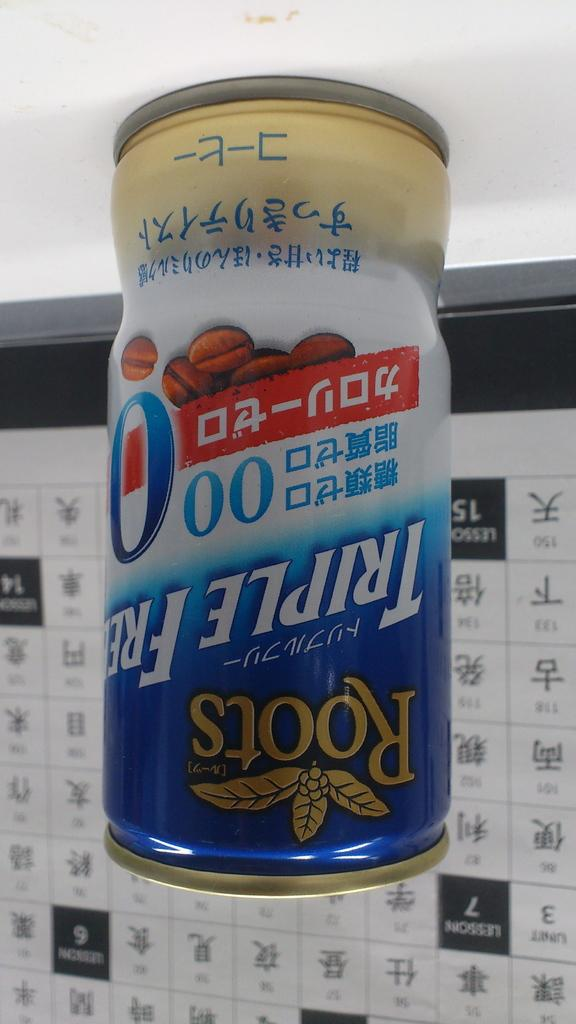<image>
Write a terse but informative summary of the picture. An upside down image of a can of Roots coffee with Japanese text on it sitting before a Japanese clalendar. 